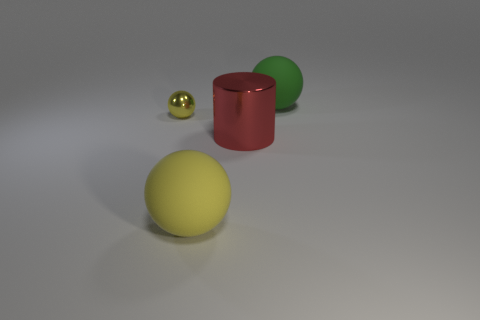Add 1 large balls. How many objects exist? 5 Subtract all spheres. How many objects are left? 1 Subtract all blue rubber cubes. Subtract all big green objects. How many objects are left? 3 Add 2 large cylinders. How many large cylinders are left? 3 Add 1 small brown shiny things. How many small brown shiny things exist? 1 Subtract 0 yellow cubes. How many objects are left? 4 